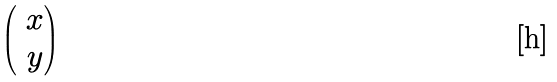<formula> <loc_0><loc_0><loc_500><loc_500>\begin{pmatrix} \ x \\ \ y \end{pmatrix}</formula> 